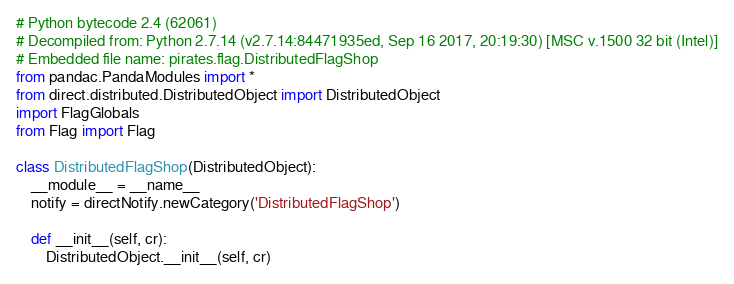Convert code to text. <code><loc_0><loc_0><loc_500><loc_500><_Python_># Python bytecode 2.4 (62061)
# Decompiled from: Python 2.7.14 (v2.7.14:84471935ed, Sep 16 2017, 20:19:30) [MSC v.1500 32 bit (Intel)]
# Embedded file name: pirates.flag.DistributedFlagShop
from pandac.PandaModules import *
from direct.distributed.DistributedObject import DistributedObject
import FlagGlobals
from Flag import Flag

class DistributedFlagShop(DistributedObject):
    __module__ = __name__
    notify = directNotify.newCategory('DistributedFlagShop')

    def __init__(self, cr):
        DistributedObject.__init__(self, cr)</code> 